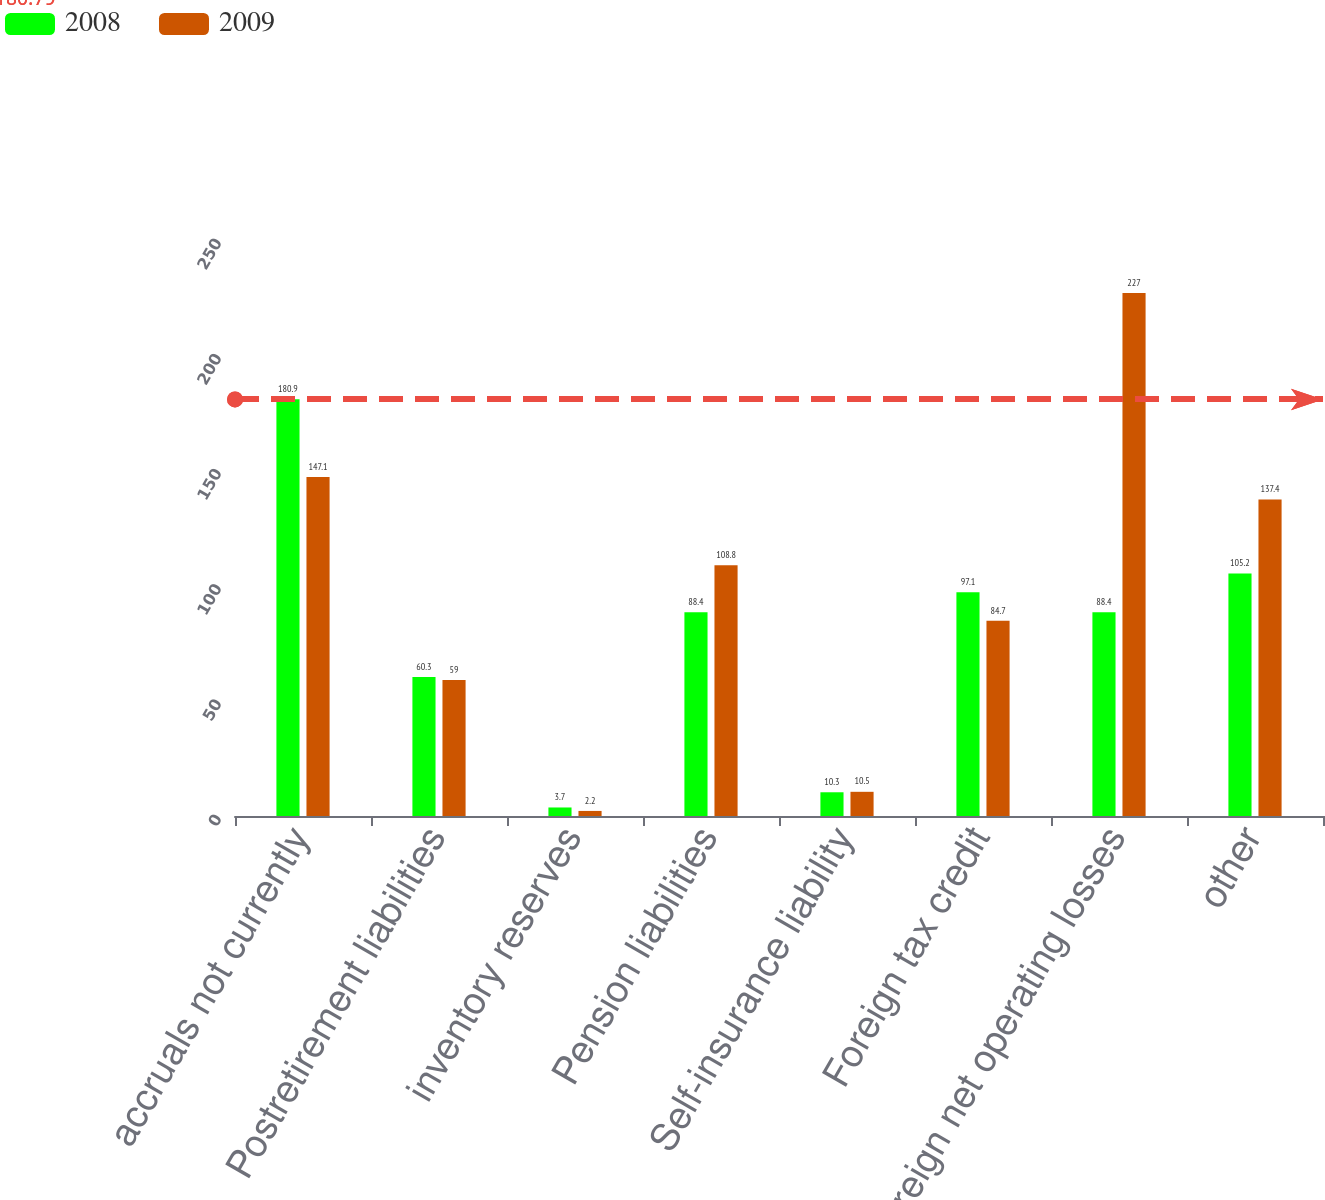Convert chart. <chart><loc_0><loc_0><loc_500><loc_500><stacked_bar_chart><ecel><fcel>accruals not currently<fcel>Postretirement liabilities<fcel>inventory reserves<fcel>Pension liabilities<fcel>Self-insurance liability<fcel>Foreign tax credit<fcel>Foreign net operating losses<fcel>other<nl><fcel>2008<fcel>180.9<fcel>60.3<fcel>3.7<fcel>88.4<fcel>10.3<fcel>97.1<fcel>88.4<fcel>105.2<nl><fcel>2009<fcel>147.1<fcel>59<fcel>2.2<fcel>108.8<fcel>10.5<fcel>84.7<fcel>227<fcel>137.4<nl></chart> 